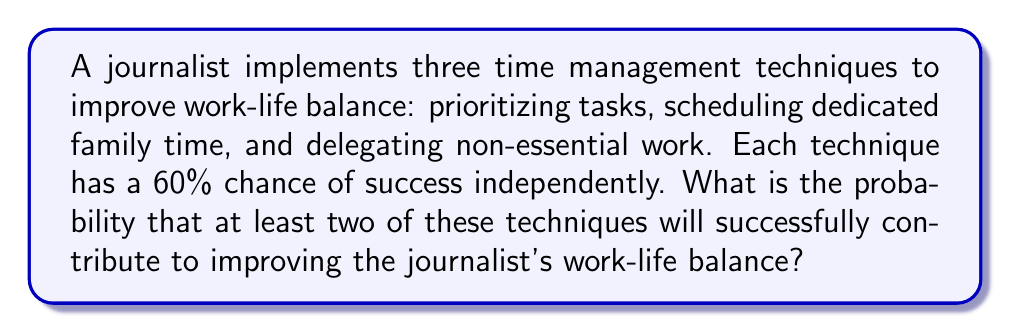Solve this math problem. Let's approach this step-by-step:

1) First, we need to define our events:
   Let A = prioritizing tasks succeeds
   Let B = scheduling dedicated family time succeeds
   Let C = delegating non-essential work succeeds

2) We're told that P(A) = P(B) = P(C) = 0.6

3) We want to find the probability of at least two techniques succeeding. This is easier to calculate by subtracting the probability of 0 or 1 technique succeeding from 1:

   P(at least 2 succeed) = 1 - P(0 or 1 succeeds)

4) To calculate P(0 or 1 succeeds), we need:
   P(0 succeed) + P(1 succeeds)

5) P(0 succeed) = P(A' ∩ B' ∩ C')
   = (1-0.6)³ = 0.4³ = 0.064

6) P(1 succeeds) = P(A succeeds alone) + P(B succeeds alone) + P(C succeeds alone)
   = P(A ∩ B' ∩ C') + P(A' ∩ B ∩ C') + P(A' ∩ B' ∩ C)
   = 0.6 * 0.4 * 0.4 + 0.4 * 0.6 * 0.4 + 0.4 * 0.4 * 0.6
   = 3 * 0.6 * 0.4² = 3 * 0.096 = 0.288

7) Therefore, P(0 or 1 succeeds) = 0.064 + 0.288 = 0.352

8) Finally, P(at least 2 succeed) = 1 - 0.352 = 0.648
Answer: 0.648 